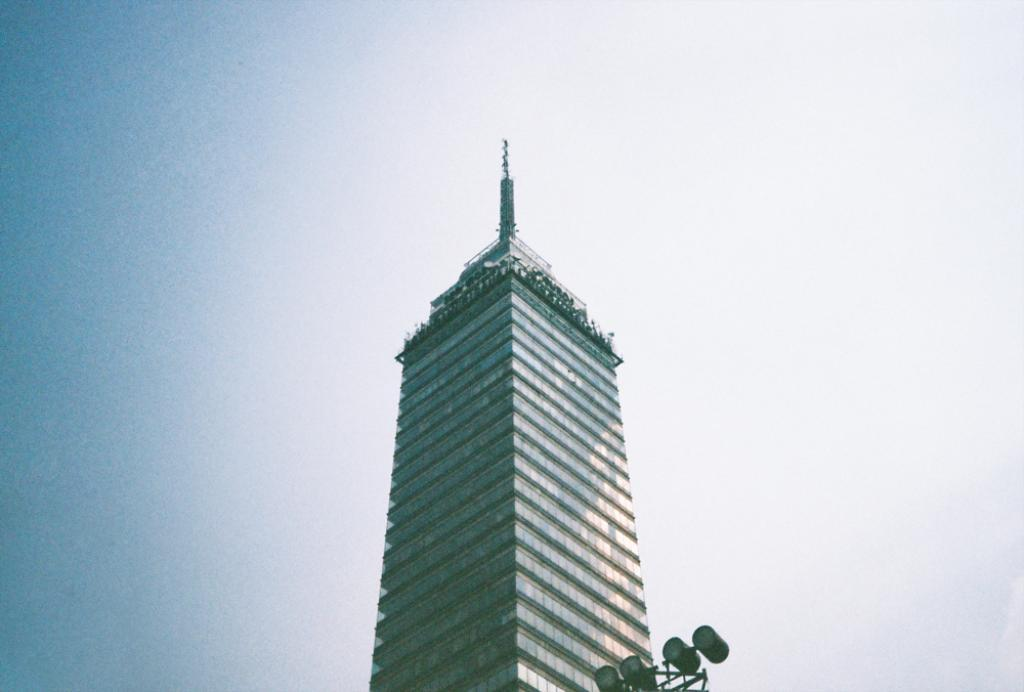What is the main subject in the foreground of the image? There is a skyscraper in the foreground of the image. What feature can be seen at the bottom of the skyscraper? Lights are present at the bottom of the skyscraper. What is visible at the top of the image? The sky is visible at the top of the image. What type of doctor is standing next to the skyscraper in the image? There is no doctor present in the image; it only features a skyscraper with lights at the bottom and the sky visible at the top. 